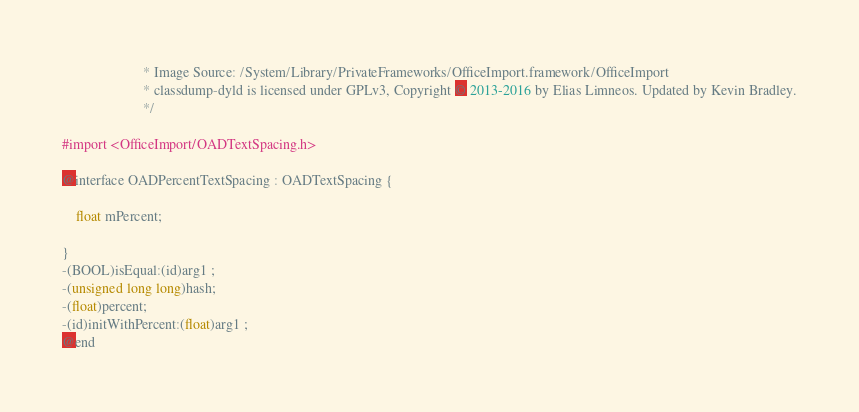Convert code to text. <code><loc_0><loc_0><loc_500><loc_500><_C_>                       * Image Source: /System/Library/PrivateFrameworks/OfficeImport.framework/OfficeImport
                       * classdump-dyld is licensed under GPLv3, Copyright © 2013-2016 by Elias Limneos. Updated by Kevin Bradley.
                       */

#import <OfficeImport/OADTextSpacing.h>

@interface OADPercentTextSpacing : OADTextSpacing {

	float mPercent;

}
-(BOOL)isEqual:(id)arg1 ;
-(unsigned long long)hash;
-(float)percent;
-(id)initWithPercent:(float)arg1 ;
@end

</code> 